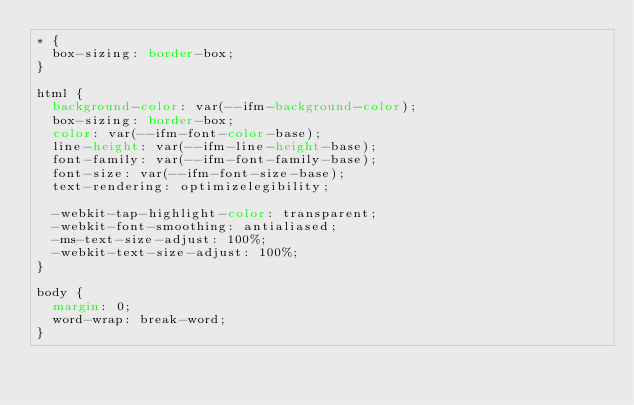<code> <loc_0><loc_0><loc_500><loc_500><_CSS_>* {
  box-sizing: border-box;
}

html {
  background-color: var(--ifm-background-color);
  box-sizing: border-box;
  color: var(--ifm-font-color-base);
  line-height: var(--ifm-line-height-base);
  font-family: var(--ifm-font-family-base);
  font-size: var(--ifm-font-size-base);
  text-rendering: optimizelegibility;

  -webkit-tap-highlight-color: transparent;
  -webkit-font-smoothing: antialiased;
  -ms-text-size-adjust: 100%;
  -webkit-text-size-adjust: 100%;
}

body {
  margin: 0;
  word-wrap: break-word;
}
</code> 